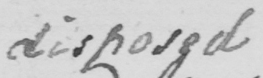Please transcribe the handwritten text in this image. disposed 